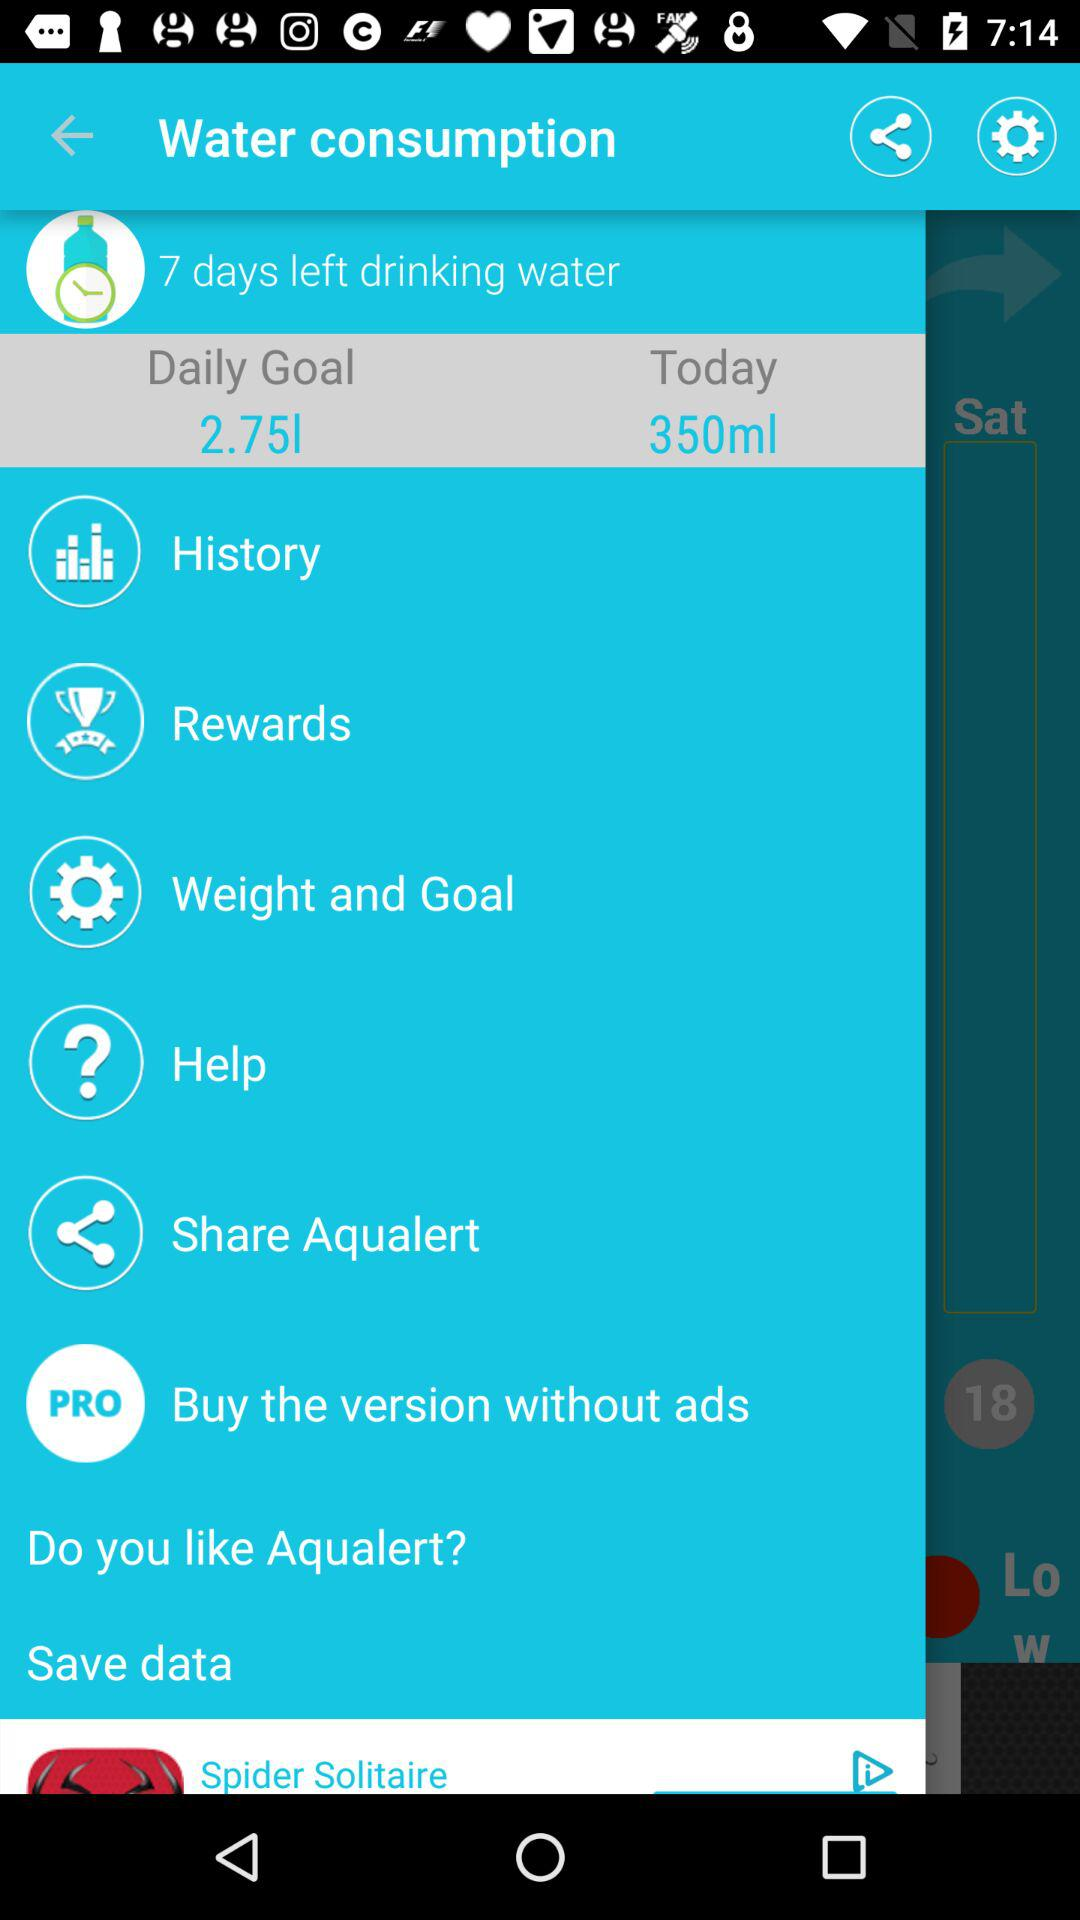How many days are left for drinking water? The number of days left is 7. 